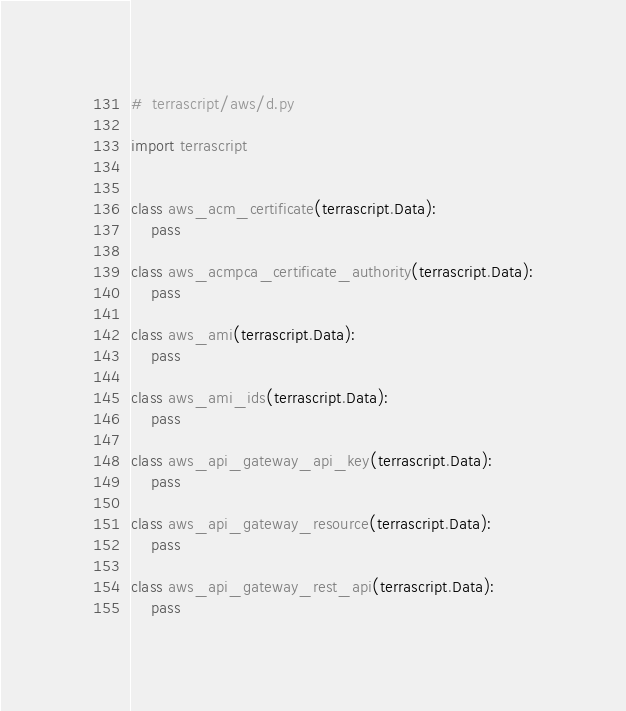Convert code to text. <code><loc_0><loc_0><loc_500><loc_500><_Python_>#  terrascript/aws/d.py

import terrascript


class aws_acm_certificate(terrascript.Data):
    pass

class aws_acmpca_certificate_authority(terrascript.Data):
    pass

class aws_ami(terrascript.Data):
    pass

class aws_ami_ids(terrascript.Data):
    pass

class aws_api_gateway_api_key(terrascript.Data):
    pass

class aws_api_gateway_resource(terrascript.Data):
    pass

class aws_api_gateway_rest_api(terrascript.Data):
    pass
</code> 